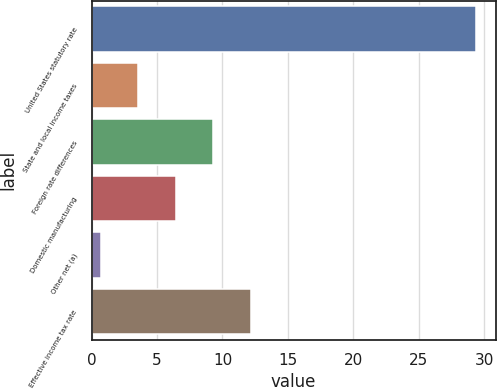<chart> <loc_0><loc_0><loc_500><loc_500><bar_chart><fcel>United States statutory rate<fcel>State and local income taxes<fcel>Foreign rate differences<fcel>Domestic manufacturing<fcel>Other net (a)<fcel>Effective income tax rate<nl><fcel>29.4<fcel>3.57<fcel>9.31<fcel>6.44<fcel>0.7<fcel>12.18<nl></chart> 